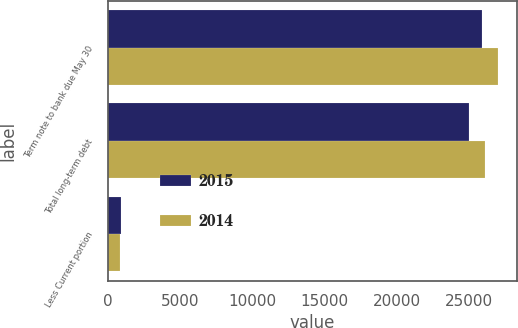Convert chart. <chart><loc_0><loc_0><loc_500><loc_500><stacked_bar_chart><ecel><fcel>Term note to bank due May 30<fcel>Total long-term debt<fcel>Less Current portion<nl><fcel>2015<fcel>25860<fcel>24974<fcel>886<nl><fcel>2014<fcel>26978<fcel>26123<fcel>855<nl></chart> 